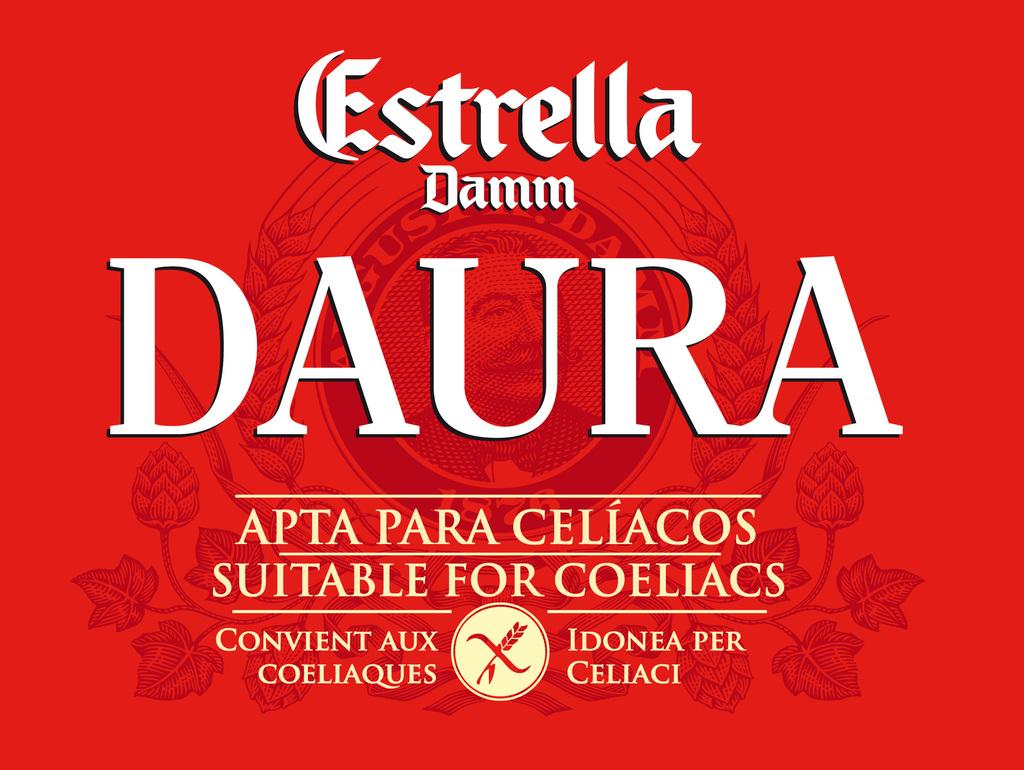What is present in the image that has a design or message? There is a poster in the image. What is the color of the poster? The poster is red in color. What colors are used for the writing on the poster? The writing on the poster is in white and cream colors. What additional feature can be seen on the poster? There is a watermark on the poster. What is depicted in the watermark? The watermark contains an image of a person. How many pears are displayed on the poster in the image? There are no pears present on the poster in the image. What is the temper of the person depicted in the watermark? The image of the person in the watermark does not convey any emotions or temper, as it is a static image. 